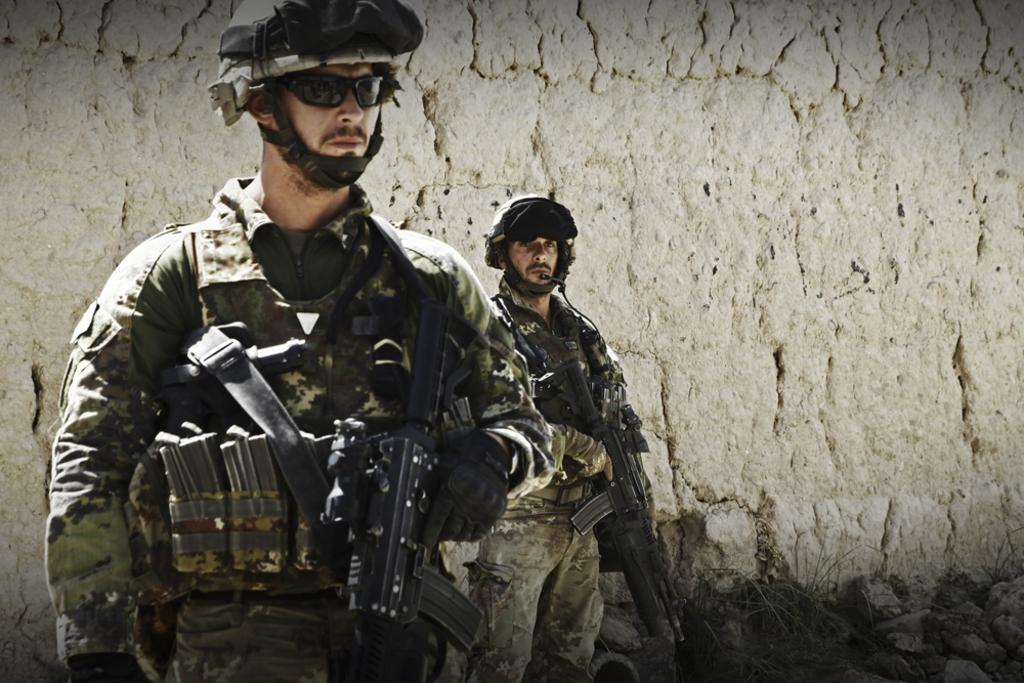How many soldiers are present in the image? There are two soldiers in the image. What are the soldiers holding in their hands? The soldiers are holding weapons in the image. What is behind the soldiers in the image? The soldiers are standing in front of a wall in the image. How many chairs are visible in the image? There are no chairs visible in the image. What type of push can be seen being performed by the soldiers in the image? There is no pushing action being performed by the soldiers in the image; they are holding weapons and standing in front of a wall. 